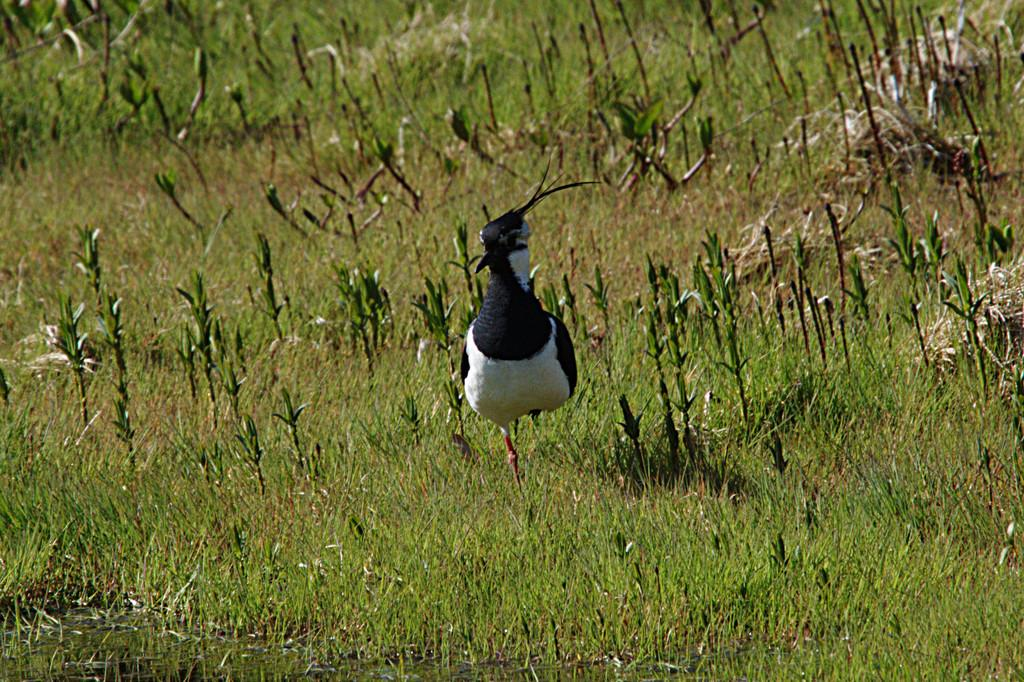What type of animal can be seen in the image? There is a bird in the image. What color is the bird in the image? The bird is in black and white color. Where is the bird located in the image? The bird is on the grass. What color is the grass in the image? The grass is in green color. How far is the bird from its manager in the image? There is no manager present in the image, and therefore no such distance can be determined. 